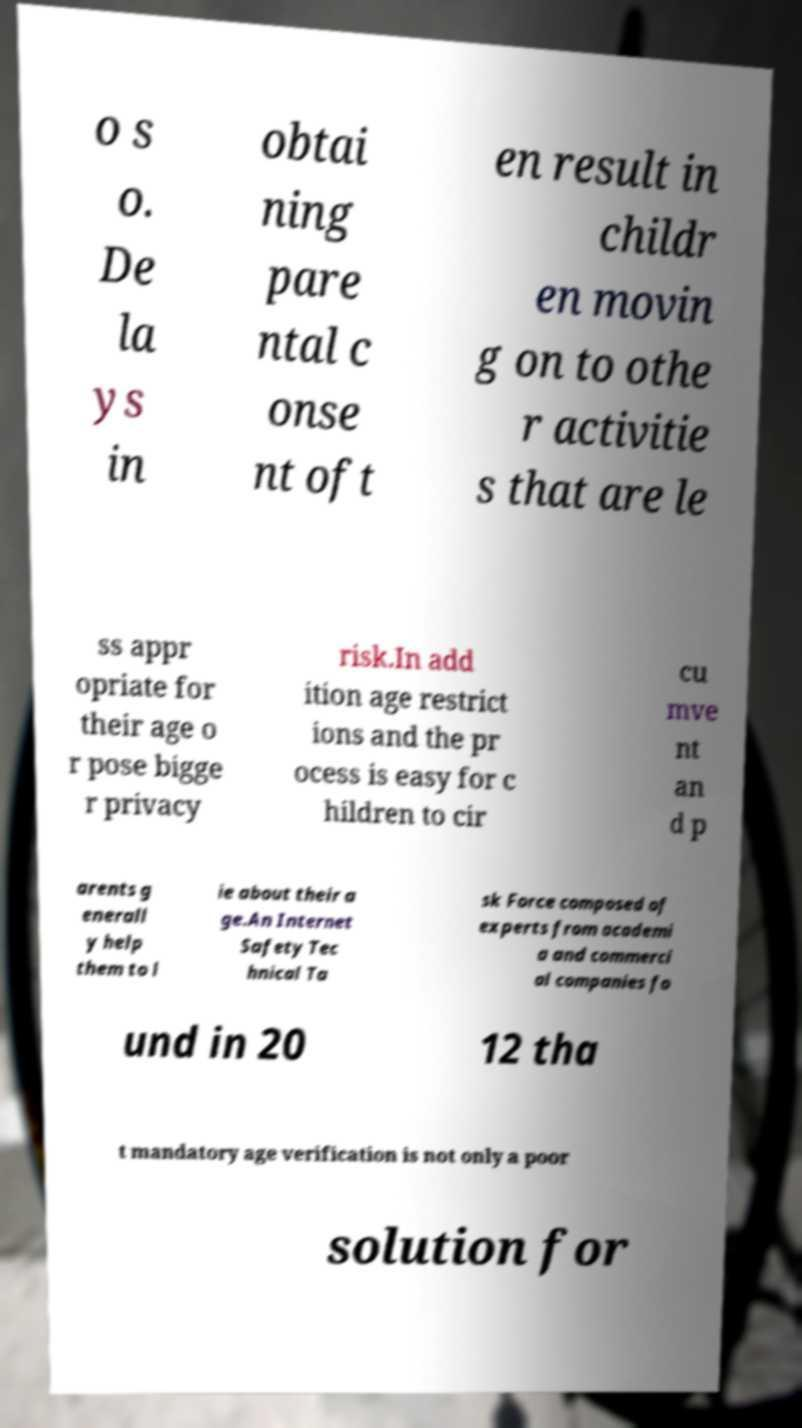Can you read and provide the text displayed in the image?This photo seems to have some interesting text. Can you extract and type it out for me? o s o. De la ys in obtai ning pare ntal c onse nt oft en result in childr en movin g on to othe r activitie s that are le ss appr opriate for their age o r pose bigge r privacy risk.In add ition age restrict ions and the pr ocess is easy for c hildren to cir cu mve nt an d p arents g enerall y help them to l ie about their a ge.An Internet Safety Tec hnical Ta sk Force composed of experts from academi a and commerci al companies fo und in 20 12 tha t mandatory age verification is not only a poor solution for 